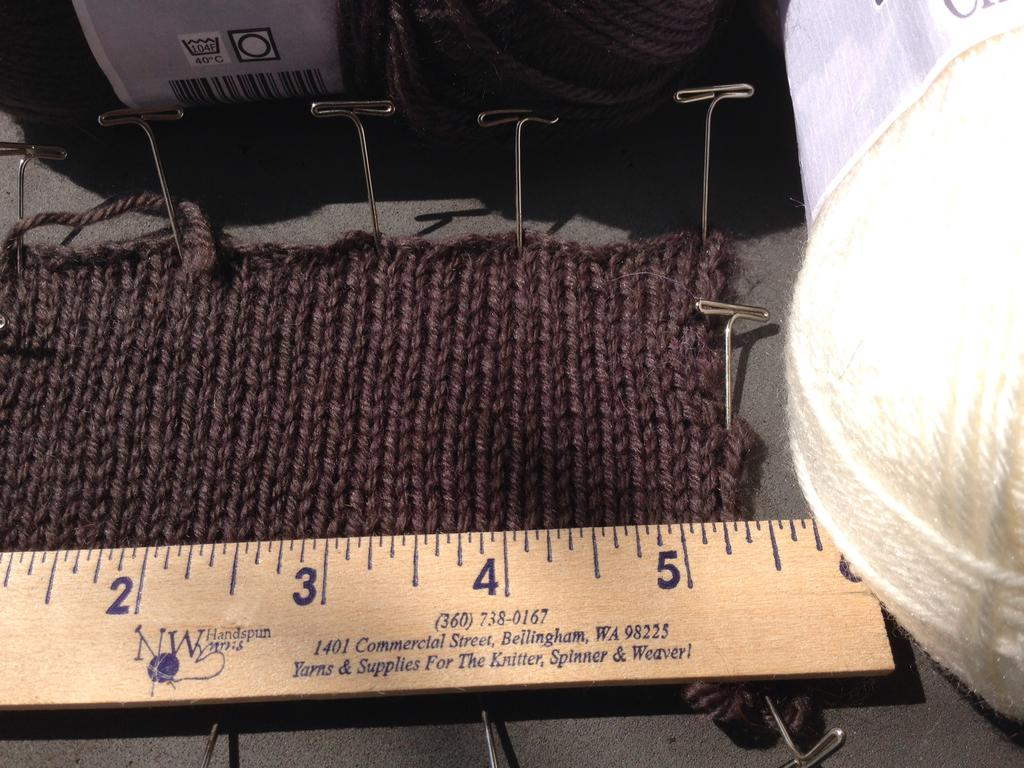<image>
Write a terse but informative summary of the picture. ruler from W handspun yarns on a piece of fabric that is pinned down 